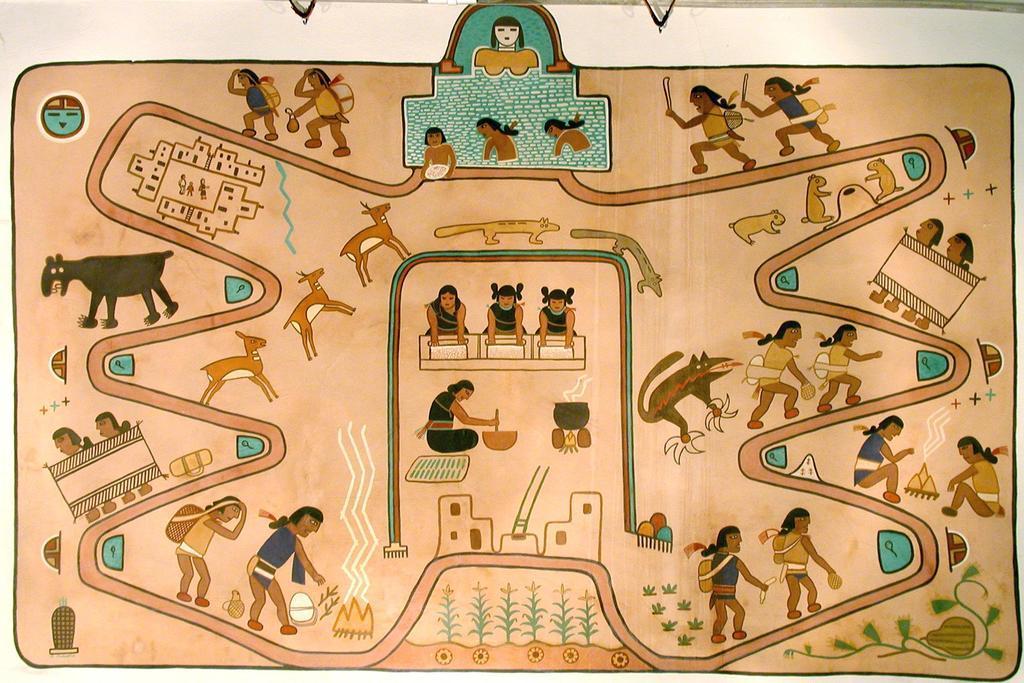How would you summarize this image in a sentence or two? This image looks like a wall painting in which I can see animals, group of people, wall, plants, grass and so on. This image is taken may be in a room. 